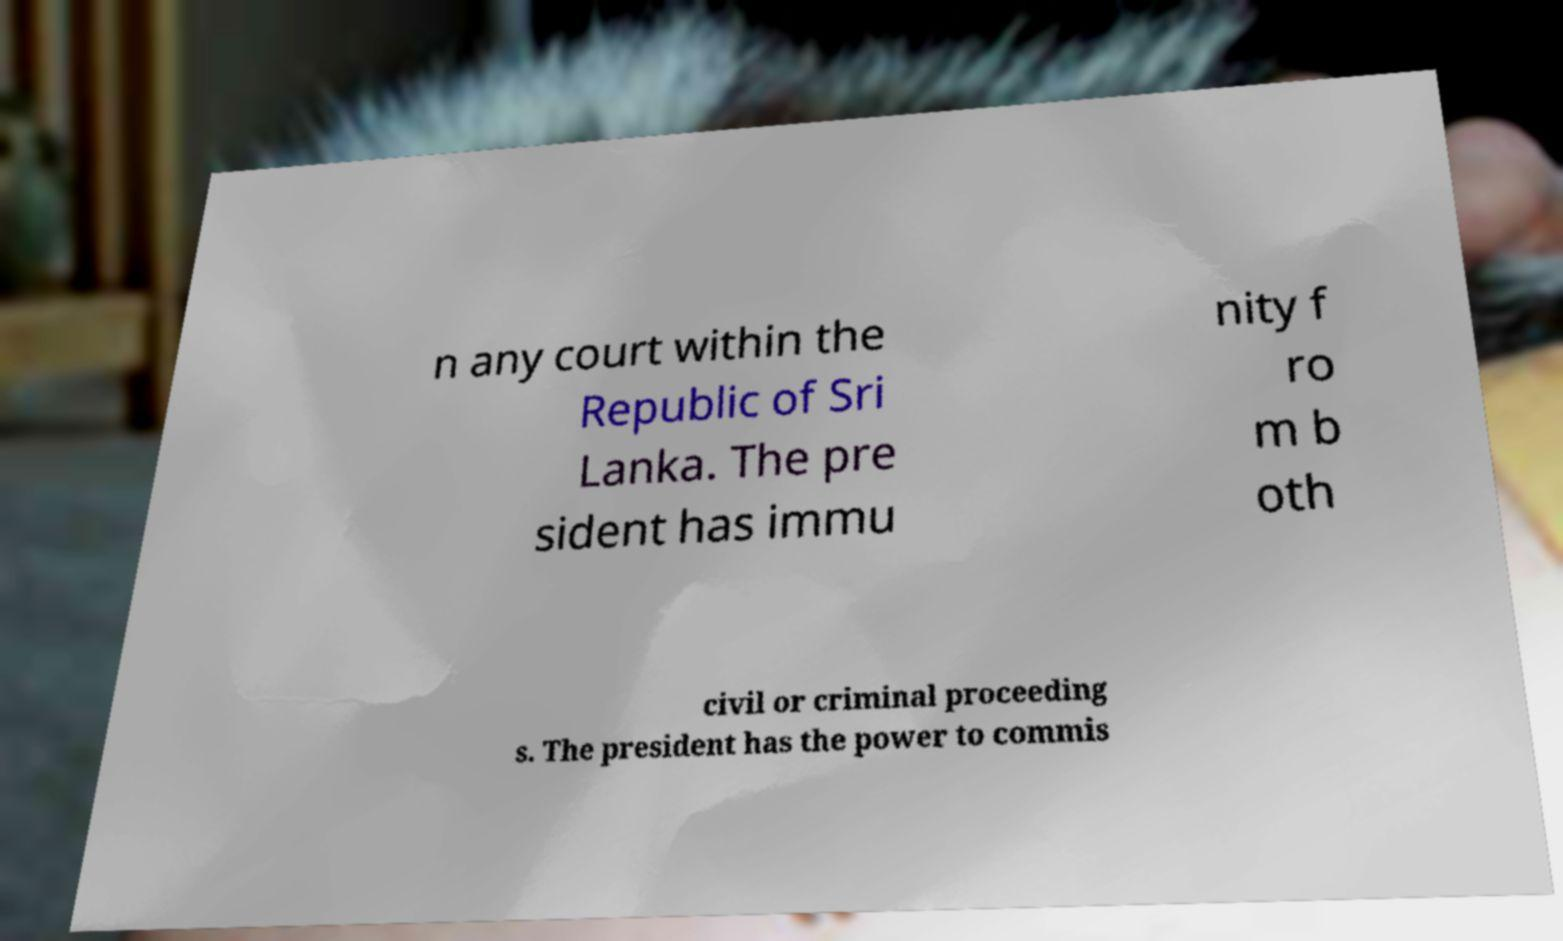For documentation purposes, I need the text within this image transcribed. Could you provide that? n any court within the Republic of Sri Lanka. The pre sident has immu nity f ro m b oth civil or criminal proceeding s. The president has the power to commis 